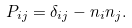Convert formula to latex. <formula><loc_0><loc_0><loc_500><loc_500>P _ { i j } = \delta _ { i j } - n _ { i } n _ { j } .</formula> 